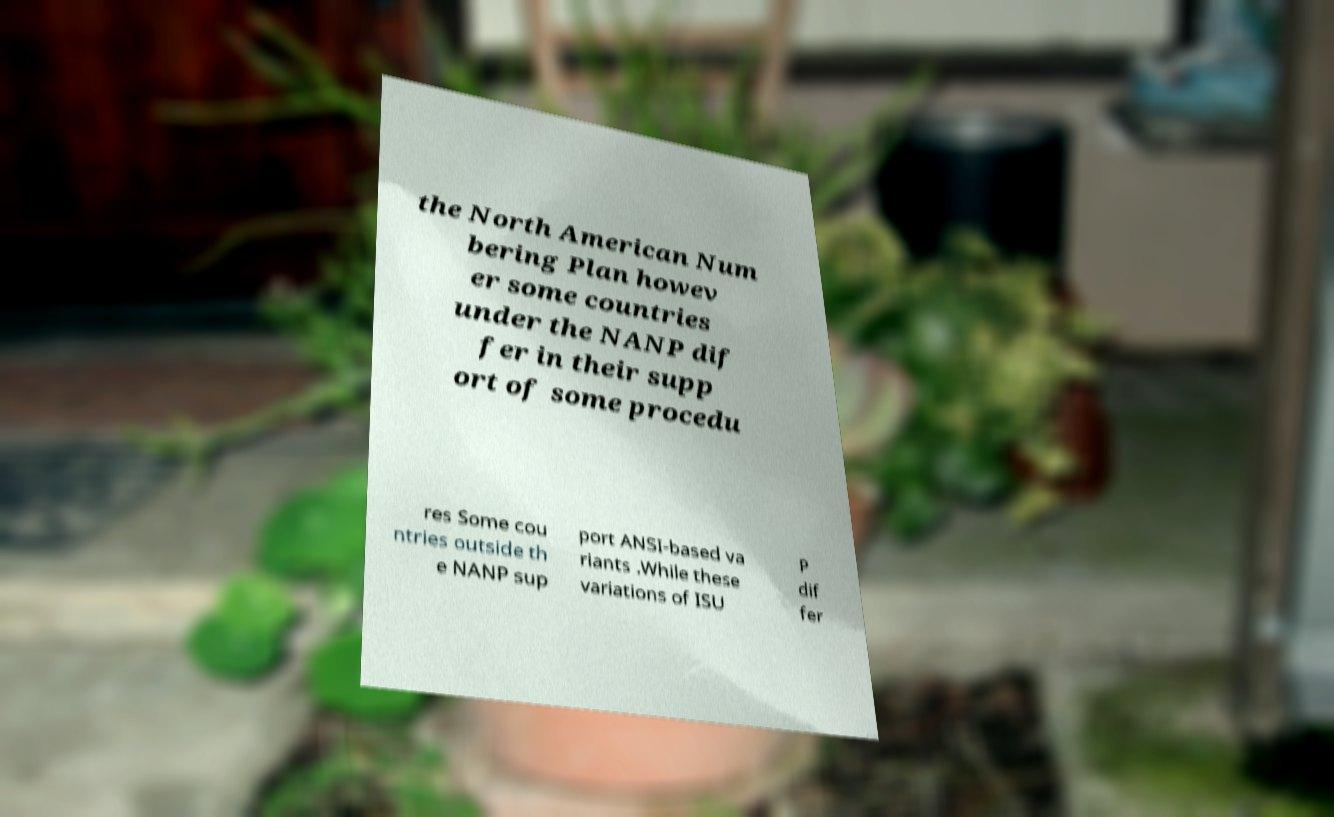Could you extract and type out the text from this image? the North American Num bering Plan howev er some countries under the NANP dif fer in their supp ort of some procedu res Some cou ntries outside th e NANP sup port ANSI-based va riants .While these variations of ISU P dif fer 